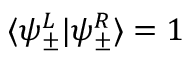Convert formula to latex. <formula><loc_0><loc_0><loc_500><loc_500>\langle \psi _ { \pm } ^ { L } | \psi _ { \pm } ^ { R } \rangle = 1</formula> 